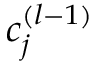<formula> <loc_0><loc_0><loc_500><loc_500>c _ { j } ^ { ( l - 1 ) }</formula> 